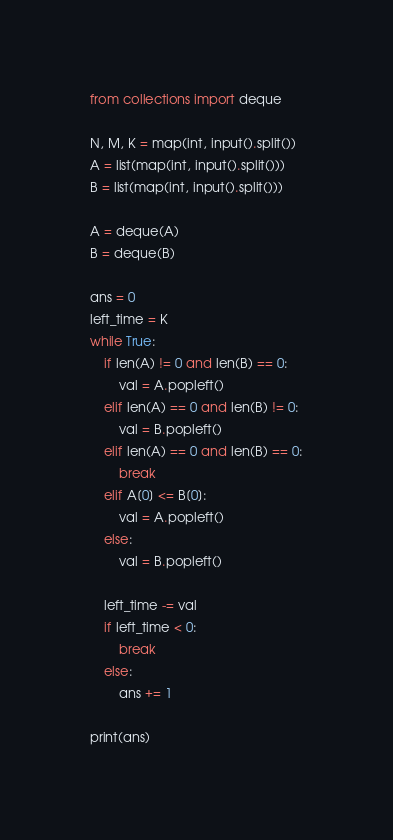Convert code to text. <code><loc_0><loc_0><loc_500><loc_500><_Python_>from collections import deque

N, M, K = map(int, input().split())
A = list(map(int, input().split()))
B = list(map(int, input().split()))

A = deque(A)
B = deque(B)

ans = 0
left_time = K
while True:
    if len(A) != 0 and len(B) == 0:
        val = A.popleft()
    elif len(A) == 0 and len(B) != 0:
        val = B.popleft()
    elif len(A) == 0 and len(B) == 0:
        break
    elif A[0] <= B[0]:
        val = A.popleft()
    else:
        val = B.popleft()

    left_time -= val
    if left_time < 0:
        break
    else:
        ans += 1

print(ans)
</code> 